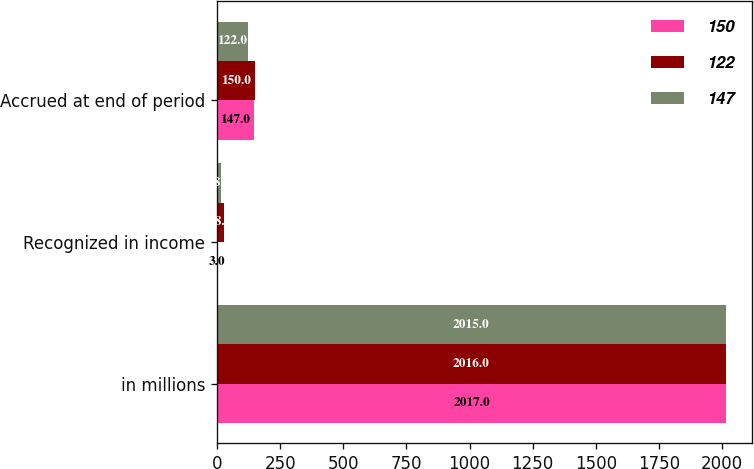<chart> <loc_0><loc_0><loc_500><loc_500><stacked_bar_chart><ecel><fcel>in millions<fcel>Recognized in income<fcel>Accrued at end of period<nl><fcel>150<fcel>2017<fcel>3<fcel>147<nl><fcel>122<fcel>2016<fcel>28<fcel>150<nl><fcel>147<fcel>2015<fcel>18<fcel>122<nl></chart> 